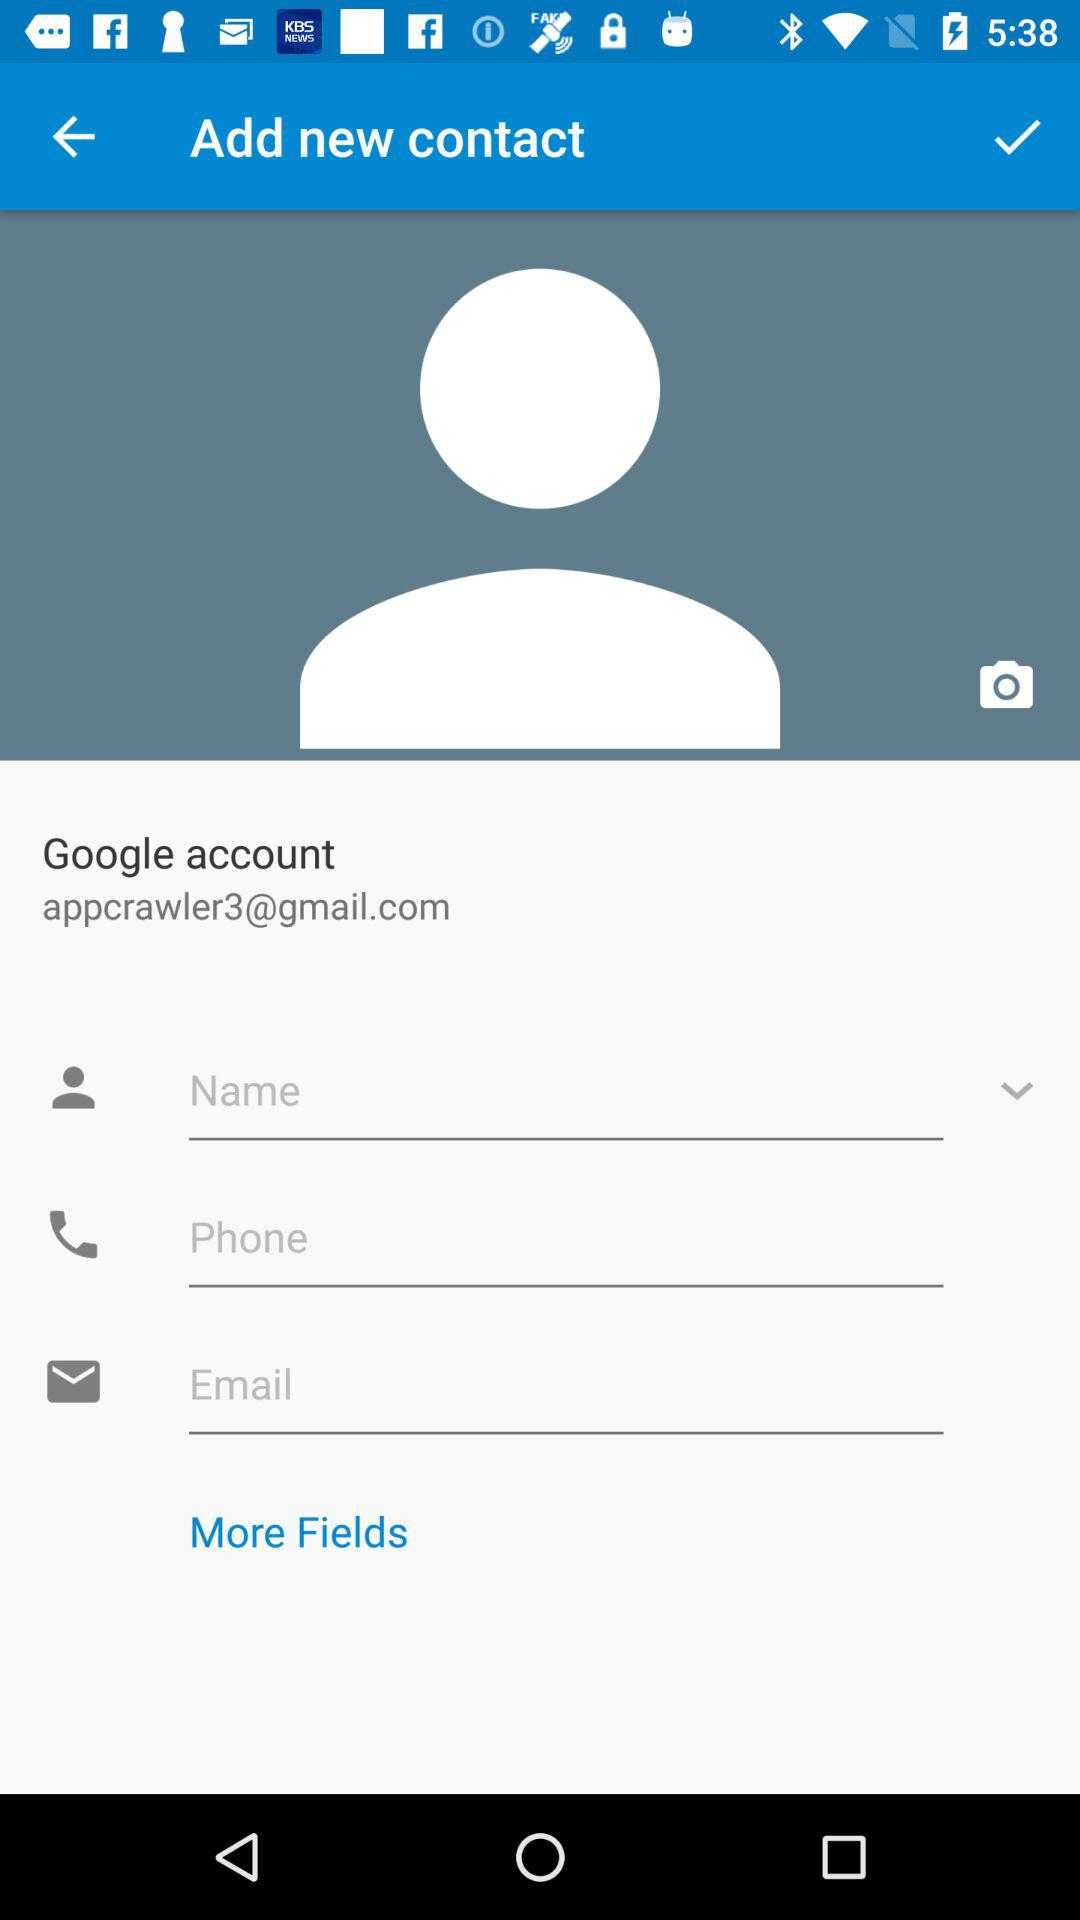What's the "Google" mail address? The "Google" mail address is appcrawler3@gmail.com. 